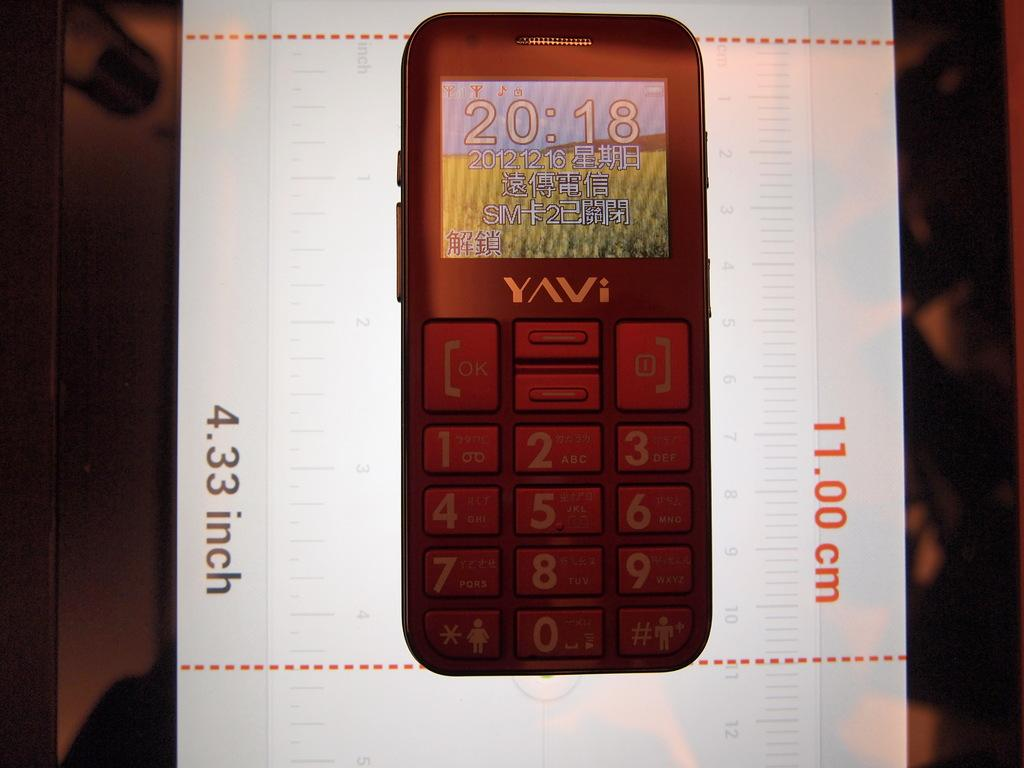Provide a one-sentence caption for the provided image. A cellphone that is 11.00 cm or 4.33 inches. 